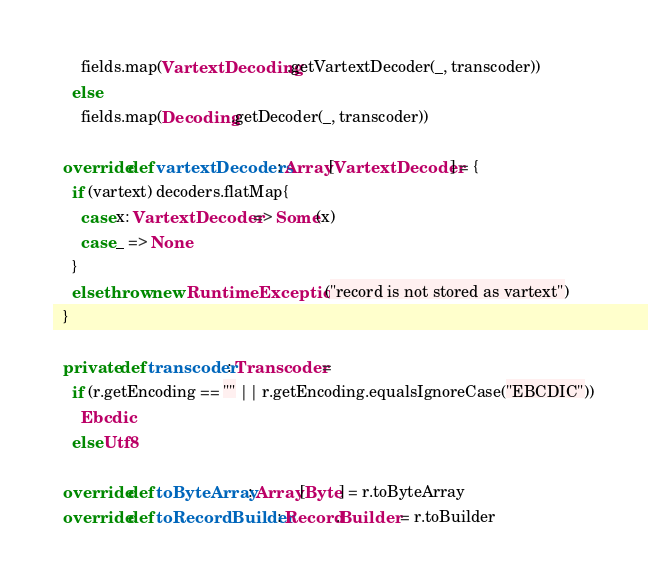<code> <loc_0><loc_0><loc_500><loc_500><_Scala_>      fields.map(VartextDecoding.getVartextDecoder(_, transcoder))
    else
      fields.map(Decoding.getDecoder(_, transcoder))

  override def vartextDecoders: Array[VartextDecoder] = {
    if (vartext) decoders.flatMap{
      case x: VartextDecoder => Some(x)
      case _ => None
    }
    else throw new RuntimeException("record is not stored as vartext")
  }

  private def transcoder: Transcoder =
    if (r.getEncoding == "" || r.getEncoding.equalsIgnoreCase("EBCDIC"))
      Ebcdic
    else Utf8

  override def toByteArray: Array[Byte] = r.toByteArray
  override def toRecordBuilder: Record.Builder = r.toBuilder</code> 